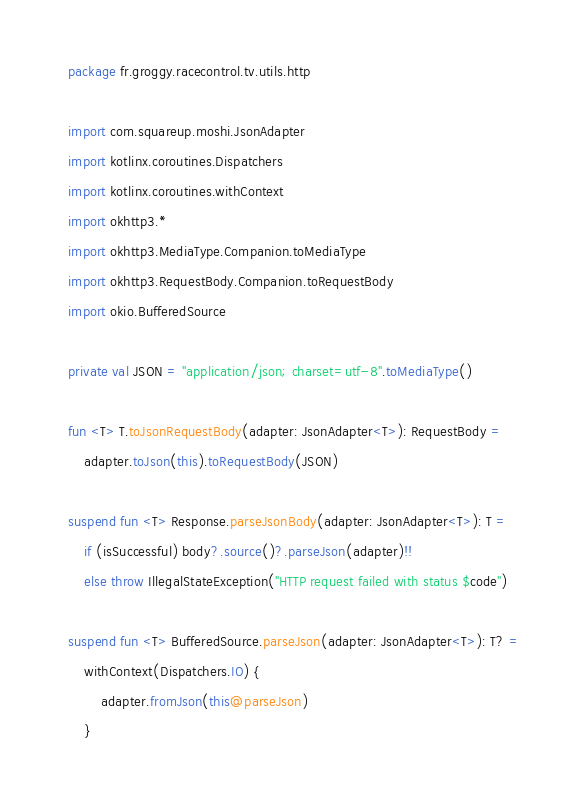<code> <loc_0><loc_0><loc_500><loc_500><_Kotlin_>package fr.groggy.racecontrol.tv.utils.http

import com.squareup.moshi.JsonAdapter
import kotlinx.coroutines.Dispatchers
import kotlinx.coroutines.withContext
import okhttp3.*
import okhttp3.MediaType.Companion.toMediaType
import okhttp3.RequestBody.Companion.toRequestBody
import okio.BufferedSource

private val JSON = "application/json; charset=utf-8".toMediaType()

fun <T> T.toJsonRequestBody(adapter: JsonAdapter<T>): RequestBody =
    adapter.toJson(this).toRequestBody(JSON)

suspend fun <T> Response.parseJsonBody(adapter: JsonAdapter<T>): T =
    if (isSuccessful) body?.source()?.parseJson(adapter)!!
    else throw IllegalStateException("HTTP request failed with status $code")

suspend fun <T> BufferedSource.parseJson(adapter: JsonAdapter<T>): T? =
    withContext(Dispatchers.IO) {
        adapter.fromJson(this@parseJson)
    }
</code> 